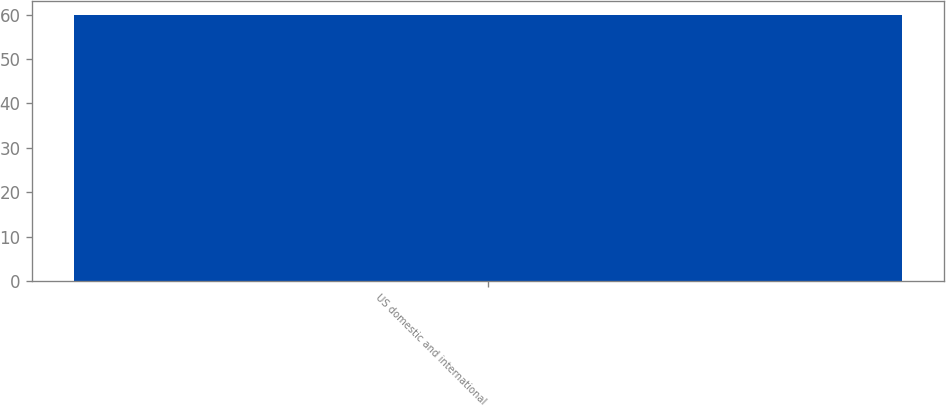Convert chart to OTSL. <chart><loc_0><loc_0><loc_500><loc_500><bar_chart><fcel>US domestic and international<nl><fcel>60<nl></chart> 